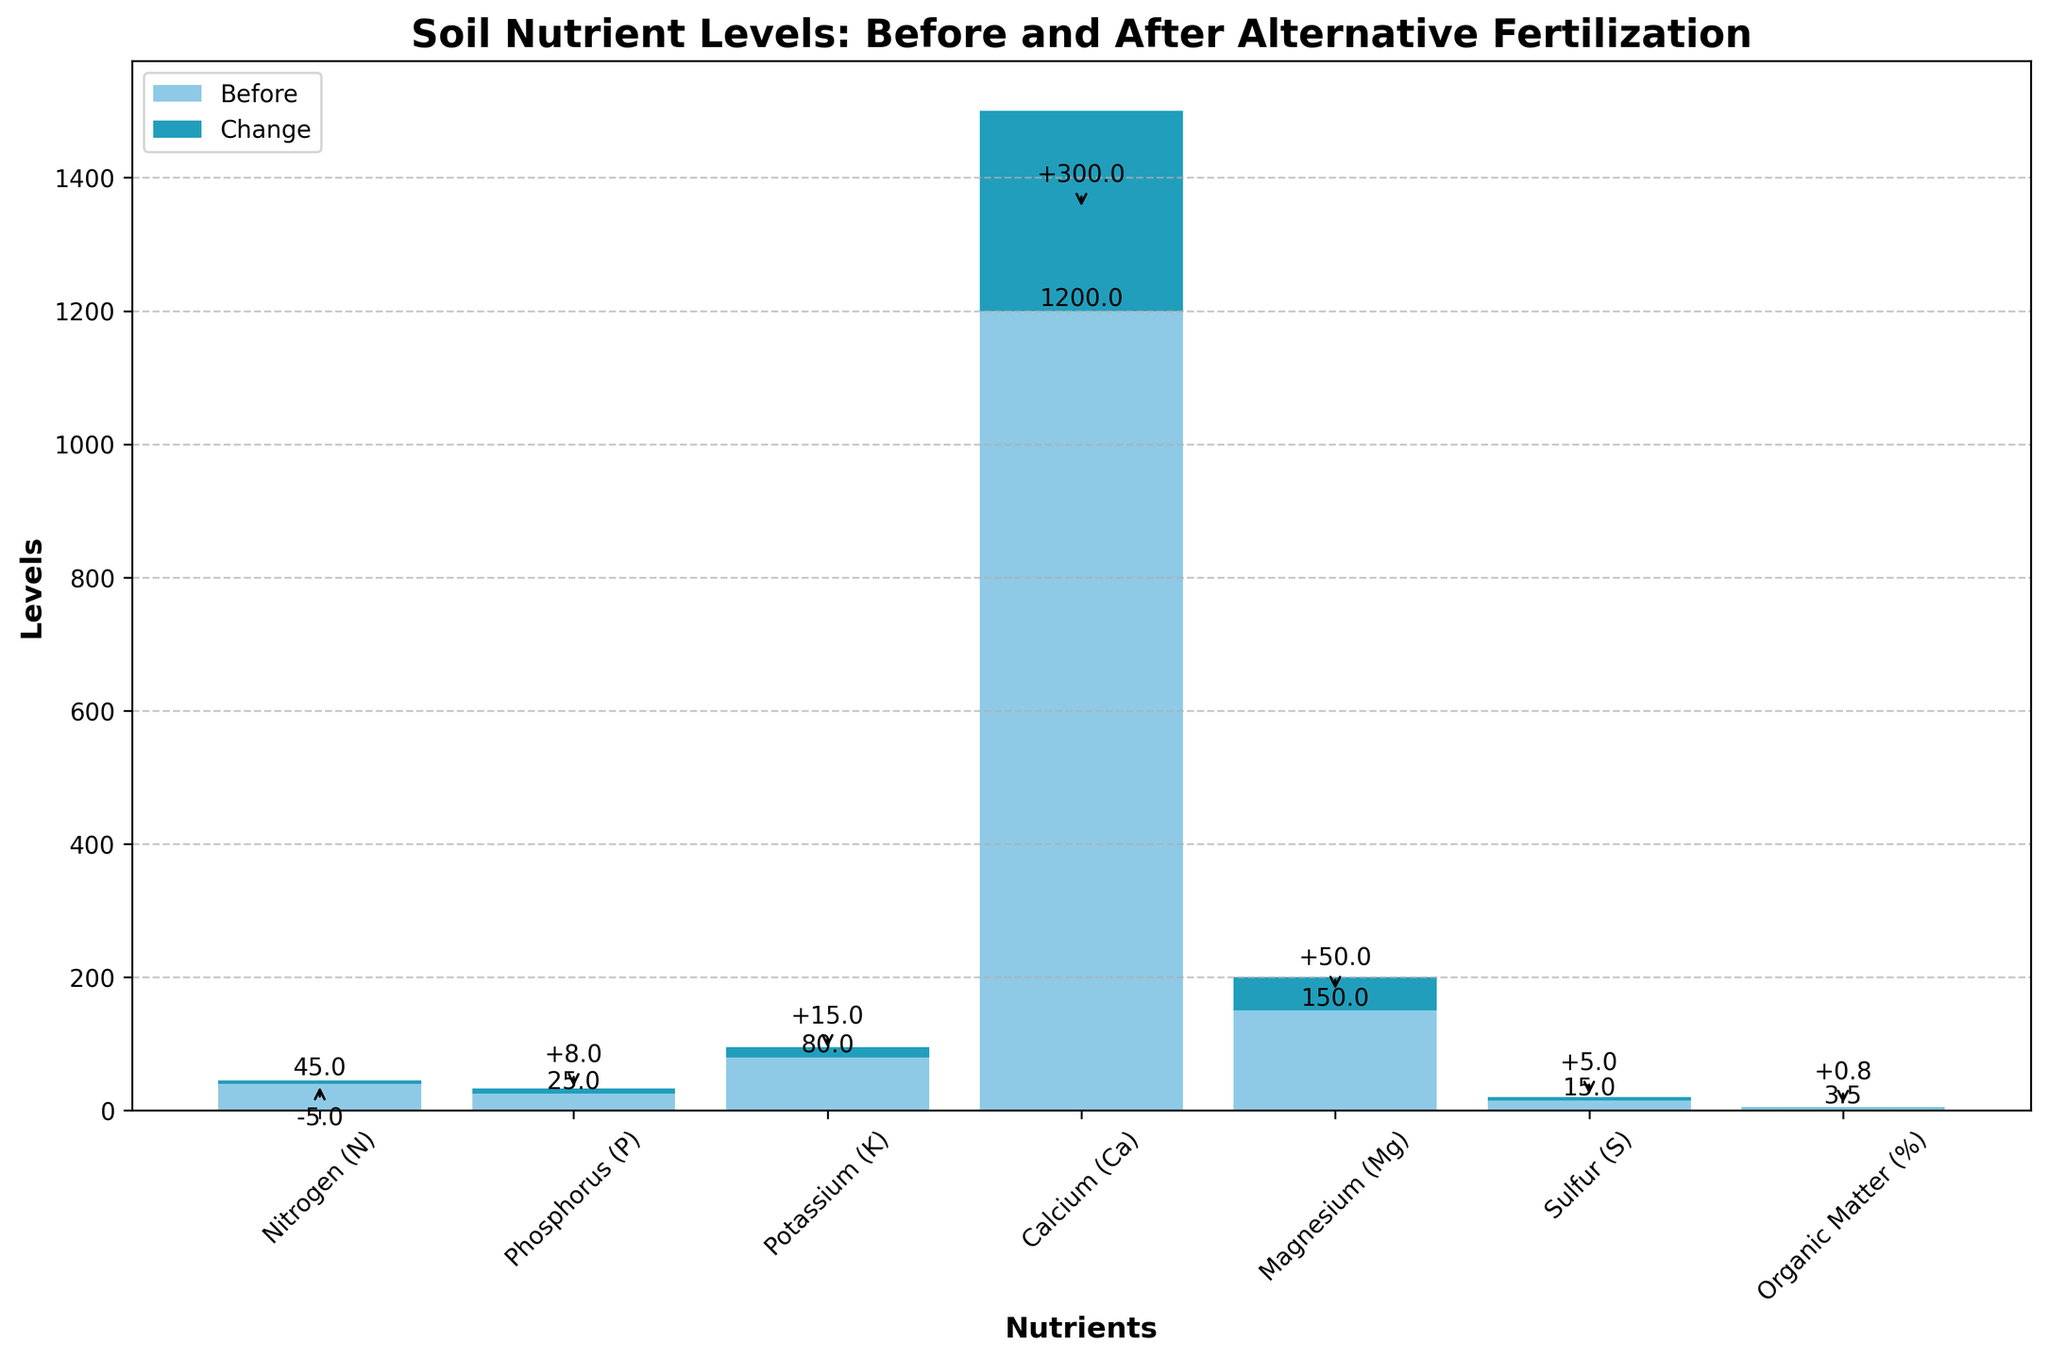what's the title of the chart? The title of the chart is displayed at the top of the figure. It provides an overview of what the chart represents. By looking at the top of the chart, you can see the title "Soil Nutrient Levels: Before and After Alternative Fertilization".
Answer: Soil Nutrient Levels: Before and After Alternative Fertilization How many nutrients are analyzed in the chart? You can count the number of different nutrient labels on the x-axis. Each bar represents a different nutrient. By counting the bars, you find that there are seven nutrients analyzed.
Answer: Seven Which nutrient shows the largest increase after implementing alternative fertilization methods? To find the largest increase, look for the bar segment that has the longest arrow or highest increase in height. The largest increase appears for Calcium (Ca), increasing by 300.
Answer: Calcium (Ca) What is the change in organic matter percentage after implementing the new fertilization methods? Locate the bar for "Organic Matter" and check the segment labeled "Change". The annotation indicates that the organic matter percentage increased by +0.8.
Answer: +0.8 What's the nitrogen level after using alternative fertilization methods? To find this, look at the nitrogen bar and sum the "Before" and "Change" values. The nitrogen "Before" value is 45 and the "Change" is -5, resulting in an "After" value of 45 - 5 = 40.
Answer: 40 Which nutrient decreased after implementing the new fertilization methods? Look for the bars where the "Change" value is negative. The nutrient with a negative change is Nitrogen (N), which decreased by 5.
Answer: Nitrogen (N) What is the overall trend in phosphorus levels after the new fertilization methods? Examine the bar for phosphorus and observe the direction and value of the change segment. The phosphorus level before was 25 and the change is +8, indicating an increase to 33.
Answer: Increase Compare the changes in Magnesium and Sulfur levels. Which one increased more? Look at the "Change" segments for both Magnesium (Mg) and Sulfur (S). Magnesium increased by 50 and Sulfur increased by 5. Therefore, Magnesium increased more.
Answer: Magnesium (Mg) Calculate the total levels of all nutrients before implementing the alternative fertilization methods. Sum up the "Before" values for all the nutrients: 45 (N) + 25 (P) + 80 (K) + 1200 (Ca) + 150 (Mg) + 15 (S) + 3.5 (Organic Matter). The total is 1518.5.
Answer: 1518.5 What's the combined total change for all nutrients after implementing the alternative fertilization methods? Sum up the "Change" values for all nutrients: -5 (N) + 8 (P) + 15 (K) + 300 (Ca) + 50 (Mg) + 5 (S) + 0.8 (Organic Matter). The total combined change is 373.8.
Answer: 373.8 